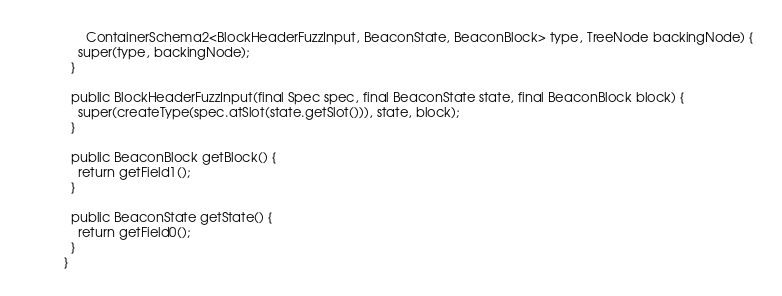<code> <loc_0><loc_0><loc_500><loc_500><_Java_>      ContainerSchema2<BlockHeaderFuzzInput, BeaconState, BeaconBlock> type, TreeNode backingNode) {
    super(type, backingNode);
  }

  public BlockHeaderFuzzInput(final Spec spec, final BeaconState state, final BeaconBlock block) {
    super(createType(spec.atSlot(state.getSlot())), state, block);
  }

  public BeaconBlock getBlock() {
    return getField1();
  }

  public BeaconState getState() {
    return getField0();
  }
}
</code> 